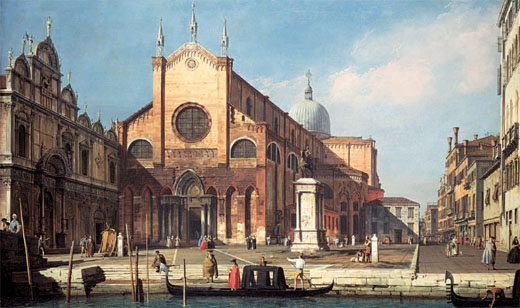What architectural influences can be seen in the church's structure? The church’s architectural structure displays a strong Gothic influence, evident from its pointed arches, intricate stonework, and large windows. The presence of the dome and twin towers indicates a blend of Byzantine and Renaissance styles that were prevalent in Venetian architecture. The detailed facades and the use of warm, reddish-brown hues are typical of the Gothic style, while the balance and elegance reflect Renaissance aesthetics. This amalgamation highlights Venice’s position as a melting pot of cultural and architectural influences throughout history. What secrets might the church’s basements hold? The church's basements, shrouded in mystery, could hold a treasure trove of secrets. Ancient relics, perhaps hidden by religious figures to protect them from looters, might be tucked away in hidden alcoves. Old manuscripts, detailing centuries of history and forgotten rituals, could lie in dust-covered chests. There might be subterranean tunnels that once provided a clandestine escape route or a means for secret gatherings. The walls of the basement might have inscriptions or symbols that tell tales of bygone legends or reveal forgotten knowledge, whispering secrets of the past to those who dare to venture below. 